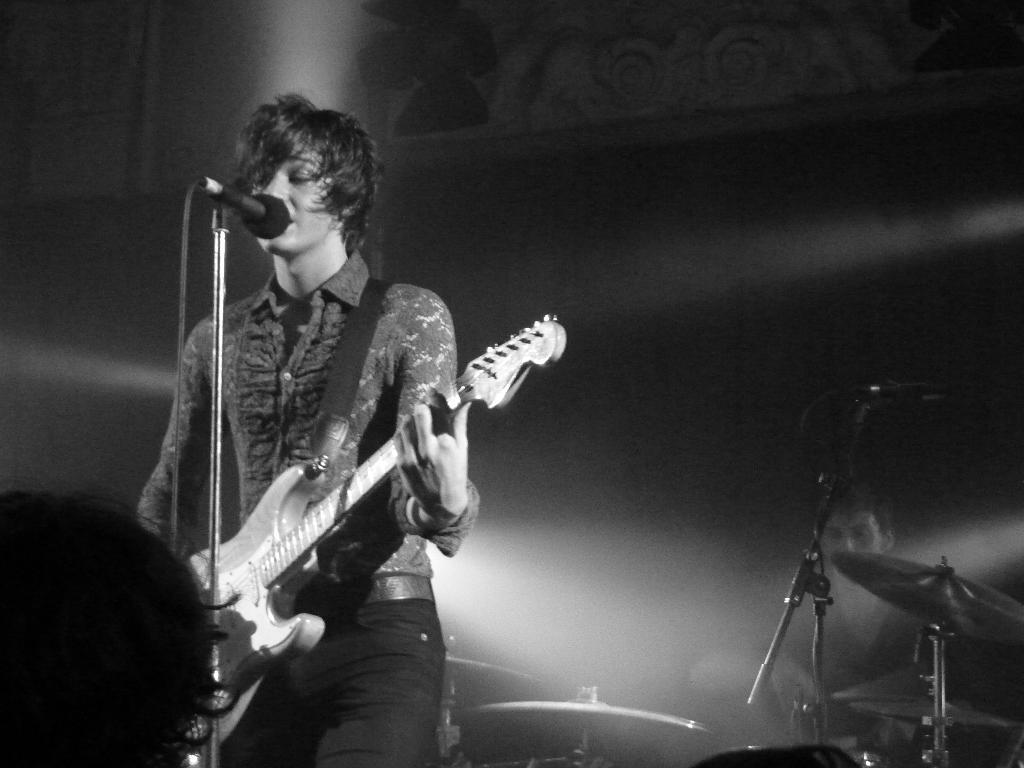What is the man in the image holding? The man is holding a guitar. What is the man doing in front of in the image? The man is in front of a microphone. Can you describe the presence of another person in the image? There is another person in the background of the image. What else can be seen in the background of the image? There is a musical instrument in the background of the image. What type of degree does the thumb have in the image? There is no thumb present in the image, and therefore no degree can be attributed to it. What kind of quilt is being used as a backdrop in the image? There is no quilt present in the image; it features a man holding a guitar, a microphone, and a musical instrument in the background. 